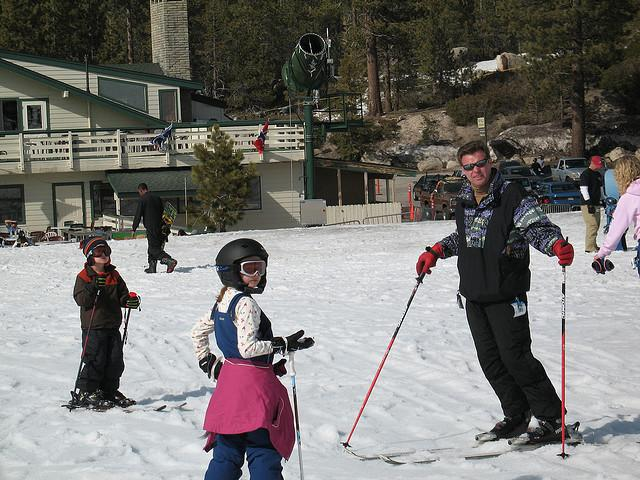What is the man in black behind the child walking away with?

Choices:
A) jacket
B) backpack
C) snowboard
D) fence snowboard 